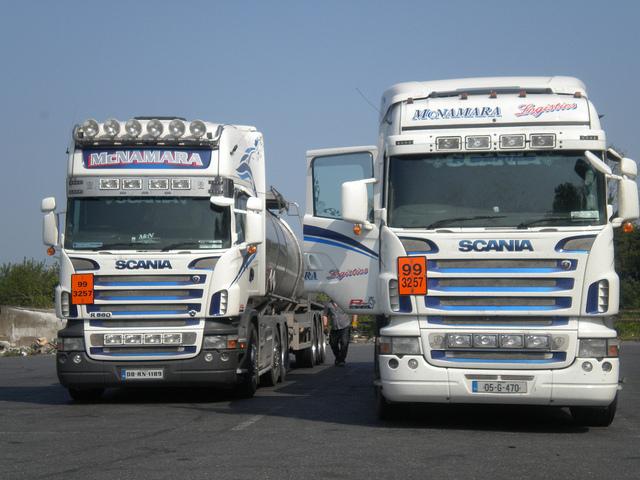How many lights are above the windshield?
Concise answer only. 4. What color is the truck on the left?
Give a very brief answer. White. What company likely owns this truck?
Concise answer only. Scania. How many trucks are there?
Answer briefly. 2. What color is the bumper on the left?
Keep it brief. Black. How many people are shown?
Be succinct. 1. What brand are these trucks?
Concise answer only. Scania. 